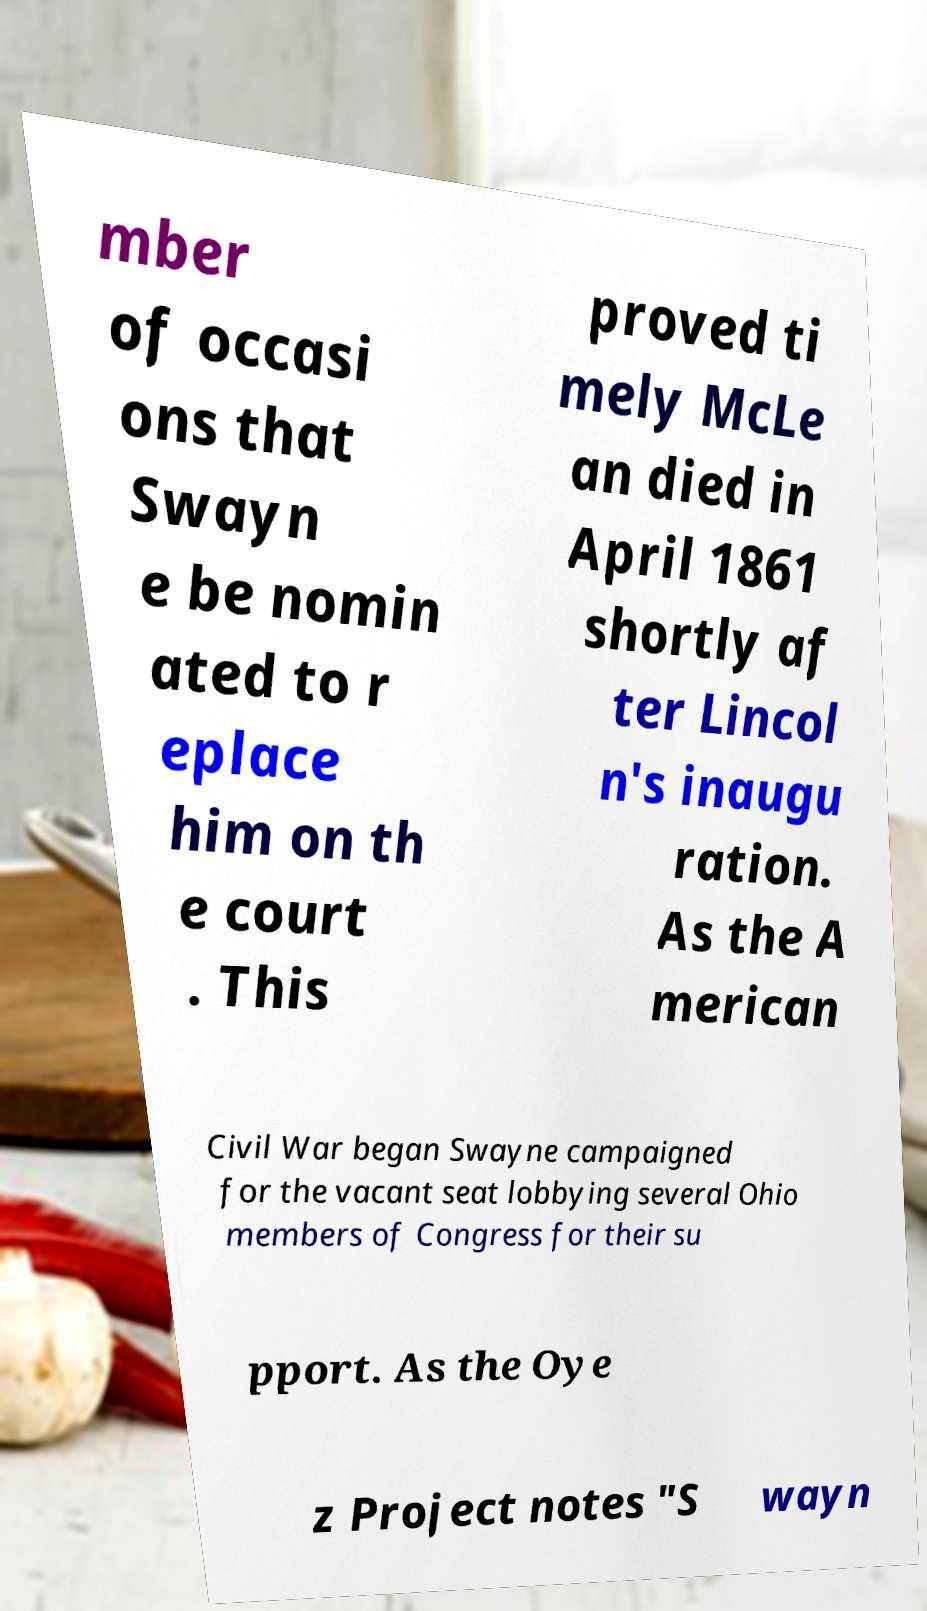I need the written content from this picture converted into text. Can you do that? mber of occasi ons that Swayn e be nomin ated to r eplace him on th e court . This proved ti mely McLe an died in April 1861 shortly af ter Lincol n's inaugu ration. As the A merican Civil War began Swayne campaigned for the vacant seat lobbying several Ohio members of Congress for their su pport. As the Oye z Project notes "S wayn 